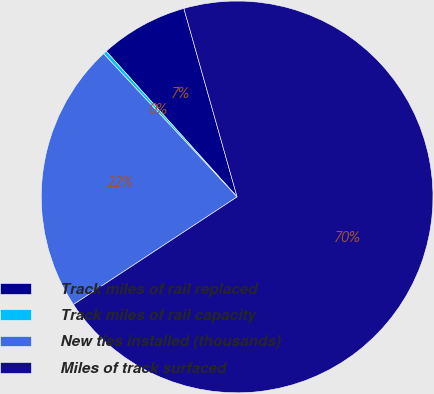Convert chart to OTSL. <chart><loc_0><loc_0><loc_500><loc_500><pie_chart><fcel>Track miles of rail replaced<fcel>Track miles of rail capacity<fcel>New ties installed (thousands)<fcel>Miles of track surfaced<nl><fcel>7.27%<fcel>0.29%<fcel>22.32%<fcel>70.13%<nl></chart> 